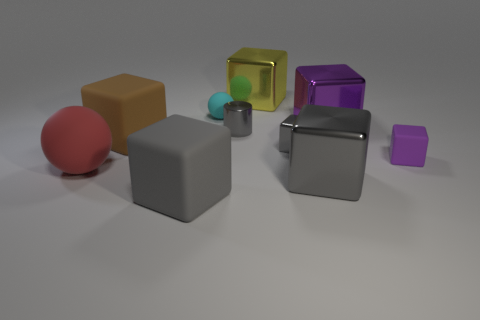Subtract all yellow blocks. How many blocks are left? 6 Subtract all red balls. How many balls are left? 1 Subtract 5 cubes. How many cubes are left? 2 Subtract all blocks. How many objects are left? 3 Subtract all brown blocks. Subtract all blue cylinders. How many blocks are left? 6 Subtract all purple balls. How many blue cylinders are left? 0 Subtract all cyan rubber objects. Subtract all red rubber objects. How many objects are left? 8 Add 2 tiny cylinders. How many tiny cylinders are left? 3 Add 9 small green objects. How many small green objects exist? 9 Subtract 0 red cubes. How many objects are left? 10 